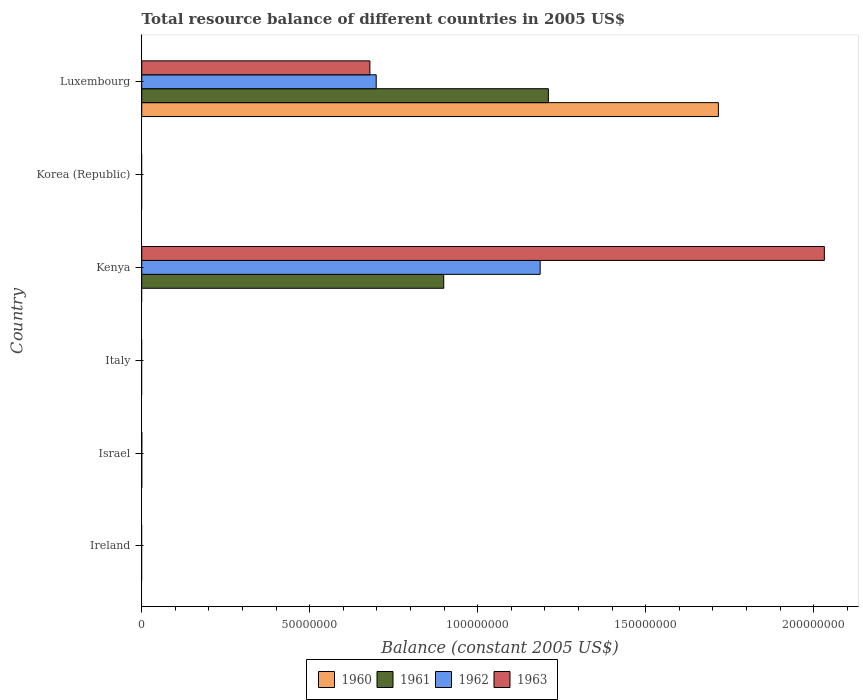How many different coloured bars are there?
Your answer should be very brief. 4. What is the label of the 2nd group of bars from the top?
Ensure brevity in your answer.  Korea (Republic). In how many cases, is the number of bars for a given country not equal to the number of legend labels?
Offer a terse response. 4. Across all countries, what is the maximum total resource balance in 1961?
Your answer should be compact. 1.21e+08. In which country was the total resource balance in 1962 maximum?
Provide a short and direct response. Kenya. What is the total total resource balance in 1960 in the graph?
Make the answer very short. 1.72e+08. What is the difference between the total resource balance in 1962 in Israel and that in Luxembourg?
Give a very brief answer. -6.98e+07. What is the average total resource balance in 1962 per country?
Offer a very short reply. 3.14e+07. What is the difference between the total resource balance in 1962 and total resource balance in 1961 in Kenya?
Give a very brief answer. 2.87e+07. What is the ratio of the total resource balance in 1963 in Israel to that in Kenya?
Your answer should be very brief. 0. Is the difference between the total resource balance in 1962 in Kenya and Luxembourg greater than the difference between the total resource balance in 1961 in Kenya and Luxembourg?
Ensure brevity in your answer.  Yes. What is the difference between the highest and the second highest total resource balance in 1961?
Make the answer very short. 3.11e+07. What is the difference between the highest and the lowest total resource balance in 1961?
Provide a short and direct response. 1.21e+08. Is the sum of the total resource balance in 1962 in Israel and Luxembourg greater than the maximum total resource balance in 1963 across all countries?
Your answer should be compact. No. Is it the case that in every country, the sum of the total resource balance in 1962 and total resource balance in 1960 is greater than the total resource balance in 1963?
Provide a succinct answer. No. How many bars are there?
Make the answer very short. 11. How many countries are there in the graph?
Provide a short and direct response. 6. Are the values on the major ticks of X-axis written in scientific E-notation?
Provide a succinct answer. No. Does the graph contain grids?
Your answer should be very brief. No. What is the title of the graph?
Keep it short and to the point. Total resource balance of different countries in 2005 US$. Does "2011" appear as one of the legend labels in the graph?
Your answer should be very brief. No. What is the label or title of the X-axis?
Your answer should be very brief. Balance (constant 2005 US$). What is the Balance (constant 2005 US$) of 1960 in Ireland?
Make the answer very short. 0. What is the Balance (constant 2005 US$) in 1961 in Ireland?
Offer a terse response. 0. What is the Balance (constant 2005 US$) of 1963 in Ireland?
Make the answer very short. 0. What is the Balance (constant 2005 US$) of 1960 in Israel?
Provide a short and direct response. 4100. What is the Balance (constant 2005 US$) in 1961 in Israel?
Offer a terse response. 2000. What is the Balance (constant 2005 US$) of 1962 in Israel?
Ensure brevity in your answer.  8000. What is the Balance (constant 2005 US$) of 1963 in Israel?
Give a very brief answer. 2.37e+04. What is the Balance (constant 2005 US$) of 1963 in Italy?
Your response must be concise. 0. What is the Balance (constant 2005 US$) in 1960 in Kenya?
Ensure brevity in your answer.  0. What is the Balance (constant 2005 US$) of 1961 in Kenya?
Offer a very short reply. 8.99e+07. What is the Balance (constant 2005 US$) of 1962 in Kenya?
Offer a terse response. 1.19e+08. What is the Balance (constant 2005 US$) of 1963 in Kenya?
Keep it short and to the point. 2.03e+08. What is the Balance (constant 2005 US$) of 1960 in Korea (Republic)?
Your response must be concise. 0. What is the Balance (constant 2005 US$) of 1961 in Korea (Republic)?
Offer a terse response. 0. What is the Balance (constant 2005 US$) in 1963 in Korea (Republic)?
Offer a very short reply. 0. What is the Balance (constant 2005 US$) in 1960 in Luxembourg?
Keep it short and to the point. 1.72e+08. What is the Balance (constant 2005 US$) in 1961 in Luxembourg?
Your response must be concise. 1.21e+08. What is the Balance (constant 2005 US$) in 1962 in Luxembourg?
Provide a short and direct response. 6.98e+07. What is the Balance (constant 2005 US$) in 1963 in Luxembourg?
Your answer should be compact. 6.79e+07. Across all countries, what is the maximum Balance (constant 2005 US$) in 1960?
Your answer should be compact. 1.72e+08. Across all countries, what is the maximum Balance (constant 2005 US$) in 1961?
Provide a short and direct response. 1.21e+08. Across all countries, what is the maximum Balance (constant 2005 US$) in 1962?
Provide a succinct answer. 1.19e+08. Across all countries, what is the maximum Balance (constant 2005 US$) in 1963?
Offer a very short reply. 2.03e+08. What is the total Balance (constant 2005 US$) in 1960 in the graph?
Offer a very short reply. 1.72e+08. What is the total Balance (constant 2005 US$) of 1961 in the graph?
Your response must be concise. 2.11e+08. What is the total Balance (constant 2005 US$) in 1962 in the graph?
Your response must be concise. 1.88e+08. What is the total Balance (constant 2005 US$) of 1963 in the graph?
Keep it short and to the point. 2.71e+08. What is the difference between the Balance (constant 2005 US$) of 1961 in Israel and that in Kenya?
Ensure brevity in your answer.  -8.99e+07. What is the difference between the Balance (constant 2005 US$) in 1962 in Israel and that in Kenya?
Provide a succinct answer. -1.19e+08. What is the difference between the Balance (constant 2005 US$) of 1963 in Israel and that in Kenya?
Give a very brief answer. -2.03e+08. What is the difference between the Balance (constant 2005 US$) in 1960 in Israel and that in Luxembourg?
Offer a very short reply. -1.72e+08. What is the difference between the Balance (constant 2005 US$) in 1961 in Israel and that in Luxembourg?
Make the answer very short. -1.21e+08. What is the difference between the Balance (constant 2005 US$) in 1962 in Israel and that in Luxembourg?
Offer a very short reply. -6.98e+07. What is the difference between the Balance (constant 2005 US$) in 1963 in Israel and that in Luxembourg?
Provide a short and direct response. -6.79e+07. What is the difference between the Balance (constant 2005 US$) of 1961 in Kenya and that in Luxembourg?
Your answer should be compact. -3.11e+07. What is the difference between the Balance (constant 2005 US$) in 1962 in Kenya and that in Luxembourg?
Give a very brief answer. 4.88e+07. What is the difference between the Balance (constant 2005 US$) of 1963 in Kenya and that in Luxembourg?
Provide a succinct answer. 1.35e+08. What is the difference between the Balance (constant 2005 US$) of 1960 in Israel and the Balance (constant 2005 US$) of 1961 in Kenya?
Provide a succinct answer. -8.99e+07. What is the difference between the Balance (constant 2005 US$) of 1960 in Israel and the Balance (constant 2005 US$) of 1962 in Kenya?
Provide a succinct answer. -1.19e+08. What is the difference between the Balance (constant 2005 US$) in 1960 in Israel and the Balance (constant 2005 US$) in 1963 in Kenya?
Your answer should be compact. -2.03e+08. What is the difference between the Balance (constant 2005 US$) of 1961 in Israel and the Balance (constant 2005 US$) of 1962 in Kenya?
Your answer should be very brief. -1.19e+08. What is the difference between the Balance (constant 2005 US$) of 1961 in Israel and the Balance (constant 2005 US$) of 1963 in Kenya?
Your answer should be compact. -2.03e+08. What is the difference between the Balance (constant 2005 US$) in 1962 in Israel and the Balance (constant 2005 US$) in 1963 in Kenya?
Your response must be concise. -2.03e+08. What is the difference between the Balance (constant 2005 US$) of 1960 in Israel and the Balance (constant 2005 US$) of 1961 in Luxembourg?
Provide a short and direct response. -1.21e+08. What is the difference between the Balance (constant 2005 US$) in 1960 in Israel and the Balance (constant 2005 US$) in 1962 in Luxembourg?
Provide a short and direct response. -6.98e+07. What is the difference between the Balance (constant 2005 US$) of 1960 in Israel and the Balance (constant 2005 US$) of 1963 in Luxembourg?
Provide a short and direct response. -6.79e+07. What is the difference between the Balance (constant 2005 US$) in 1961 in Israel and the Balance (constant 2005 US$) in 1962 in Luxembourg?
Offer a very short reply. -6.98e+07. What is the difference between the Balance (constant 2005 US$) in 1961 in Israel and the Balance (constant 2005 US$) in 1963 in Luxembourg?
Ensure brevity in your answer.  -6.79e+07. What is the difference between the Balance (constant 2005 US$) in 1962 in Israel and the Balance (constant 2005 US$) in 1963 in Luxembourg?
Provide a succinct answer. -6.79e+07. What is the difference between the Balance (constant 2005 US$) in 1961 in Kenya and the Balance (constant 2005 US$) in 1962 in Luxembourg?
Your response must be concise. 2.01e+07. What is the difference between the Balance (constant 2005 US$) of 1961 in Kenya and the Balance (constant 2005 US$) of 1963 in Luxembourg?
Your answer should be very brief. 2.20e+07. What is the difference between the Balance (constant 2005 US$) of 1962 in Kenya and the Balance (constant 2005 US$) of 1963 in Luxembourg?
Offer a terse response. 5.07e+07. What is the average Balance (constant 2005 US$) in 1960 per country?
Keep it short and to the point. 2.86e+07. What is the average Balance (constant 2005 US$) in 1961 per country?
Give a very brief answer. 3.52e+07. What is the average Balance (constant 2005 US$) of 1962 per country?
Offer a very short reply. 3.14e+07. What is the average Balance (constant 2005 US$) in 1963 per country?
Your answer should be very brief. 4.52e+07. What is the difference between the Balance (constant 2005 US$) in 1960 and Balance (constant 2005 US$) in 1961 in Israel?
Ensure brevity in your answer.  2100. What is the difference between the Balance (constant 2005 US$) of 1960 and Balance (constant 2005 US$) of 1962 in Israel?
Offer a very short reply. -3900. What is the difference between the Balance (constant 2005 US$) in 1960 and Balance (constant 2005 US$) in 1963 in Israel?
Your response must be concise. -1.96e+04. What is the difference between the Balance (constant 2005 US$) of 1961 and Balance (constant 2005 US$) of 1962 in Israel?
Your answer should be compact. -6000. What is the difference between the Balance (constant 2005 US$) of 1961 and Balance (constant 2005 US$) of 1963 in Israel?
Offer a very short reply. -2.17e+04. What is the difference between the Balance (constant 2005 US$) of 1962 and Balance (constant 2005 US$) of 1963 in Israel?
Your answer should be compact. -1.57e+04. What is the difference between the Balance (constant 2005 US$) in 1961 and Balance (constant 2005 US$) in 1962 in Kenya?
Offer a very short reply. -2.87e+07. What is the difference between the Balance (constant 2005 US$) of 1961 and Balance (constant 2005 US$) of 1963 in Kenya?
Your answer should be very brief. -1.13e+08. What is the difference between the Balance (constant 2005 US$) of 1962 and Balance (constant 2005 US$) of 1963 in Kenya?
Offer a very short reply. -8.46e+07. What is the difference between the Balance (constant 2005 US$) in 1960 and Balance (constant 2005 US$) in 1961 in Luxembourg?
Your answer should be compact. 5.06e+07. What is the difference between the Balance (constant 2005 US$) in 1960 and Balance (constant 2005 US$) in 1962 in Luxembourg?
Provide a short and direct response. 1.02e+08. What is the difference between the Balance (constant 2005 US$) of 1960 and Balance (constant 2005 US$) of 1963 in Luxembourg?
Your answer should be very brief. 1.04e+08. What is the difference between the Balance (constant 2005 US$) of 1961 and Balance (constant 2005 US$) of 1962 in Luxembourg?
Provide a short and direct response. 5.12e+07. What is the difference between the Balance (constant 2005 US$) of 1961 and Balance (constant 2005 US$) of 1963 in Luxembourg?
Provide a short and direct response. 5.31e+07. What is the difference between the Balance (constant 2005 US$) in 1962 and Balance (constant 2005 US$) in 1963 in Luxembourg?
Your answer should be compact. 1.88e+06. What is the ratio of the Balance (constant 2005 US$) of 1961 in Israel to that in Kenya?
Keep it short and to the point. 0. What is the ratio of the Balance (constant 2005 US$) of 1962 in Israel to that in Kenya?
Your answer should be compact. 0. What is the ratio of the Balance (constant 2005 US$) of 1962 in Israel to that in Luxembourg?
Your answer should be very brief. 0. What is the ratio of the Balance (constant 2005 US$) of 1961 in Kenya to that in Luxembourg?
Keep it short and to the point. 0.74. What is the ratio of the Balance (constant 2005 US$) in 1962 in Kenya to that in Luxembourg?
Ensure brevity in your answer.  1.7. What is the ratio of the Balance (constant 2005 US$) of 1963 in Kenya to that in Luxembourg?
Give a very brief answer. 2.99. What is the difference between the highest and the second highest Balance (constant 2005 US$) in 1961?
Give a very brief answer. 3.11e+07. What is the difference between the highest and the second highest Balance (constant 2005 US$) of 1962?
Your response must be concise. 4.88e+07. What is the difference between the highest and the second highest Balance (constant 2005 US$) in 1963?
Provide a short and direct response. 1.35e+08. What is the difference between the highest and the lowest Balance (constant 2005 US$) of 1960?
Provide a short and direct response. 1.72e+08. What is the difference between the highest and the lowest Balance (constant 2005 US$) of 1961?
Keep it short and to the point. 1.21e+08. What is the difference between the highest and the lowest Balance (constant 2005 US$) of 1962?
Give a very brief answer. 1.19e+08. What is the difference between the highest and the lowest Balance (constant 2005 US$) in 1963?
Provide a short and direct response. 2.03e+08. 